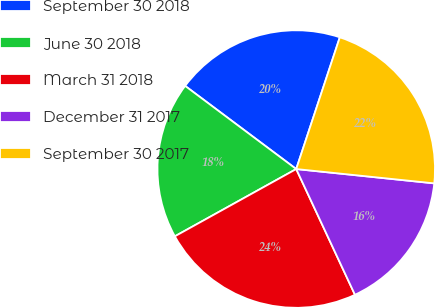Convert chart to OTSL. <chart><loc_0><loc_0><loc_500><loc_500><pie_chart><fcel>September 30 2018<fcel>June 30 2018<fcel>March 31 2018<fcel>December 31 2017<fcel>September 30 2017<nl><fcel>19.86%<fcel>18.28%<fcel>23.9%<fcel>16.4%<fcel>21.56%<nl></chart> 